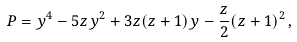Convert formula to latex. <formula><loc_0><loc_0><loc_500><loc_500>P = y ^ { 4 } - 5 z y ^ { 2 } + 3 z ( z + 1 ) y - \frac { z } { 2 } ( z + 1 ) ^ { 2 } \, ,</formula> 